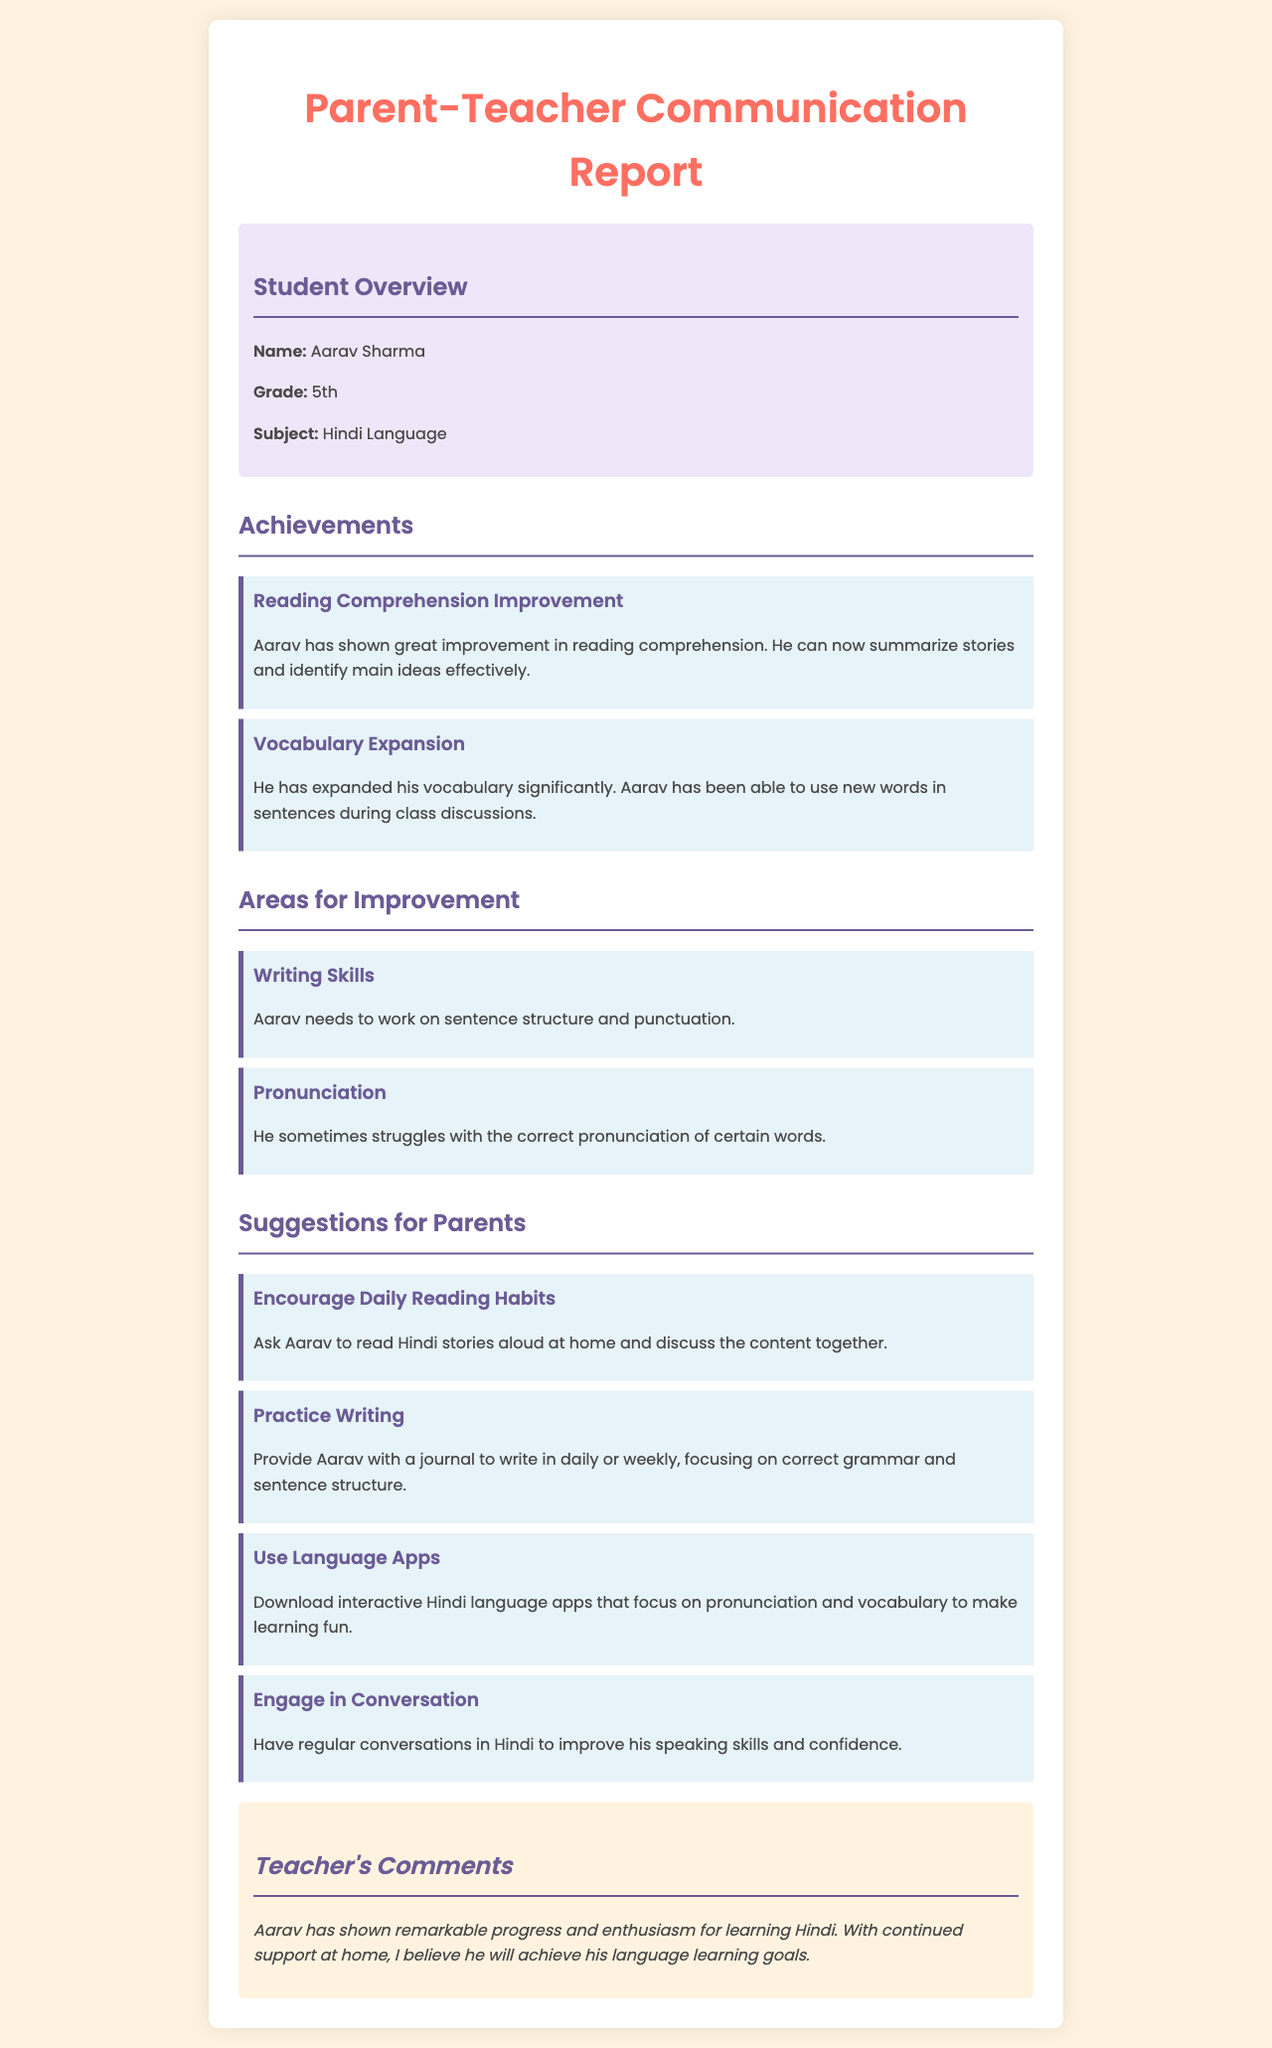What is the student's name? The student's name is clearly stated in the "Student Overview" section.
Answer: Aarav Sharma What grade is Aarav in? The grade of the student is mentioned in the same "Student Overview" section.
Answer: 5th What subject is this report focusing on? The subject for which the achievements and areas for improvement are listed is specified in the "Student Overview" section.
Answer: Hindi Language What area needs improvement related to writing? This information is found in the "Areas for Improvement" section specifically about writing skills.
Answer: Sentence structure and punctuation What has Aarav shown great improvement in? The specific achievement is detailed in the "Achievements" section focusing on reading comprehension.
Answer: Reading comprehension How should parents encourage reading habits? This suggestion is outlined in the "Suggestions for Parents" section regarding daily reading practices.
Answer: Read Hindi stories aloud What tool can parents use to improve pronunciation? This suggestion can be found in the "Suggestions for Parents" section that mentions language apps.
Answer: Language apps What does the teacher think about Aarav's progress? The teacher's overall opinion about the student's progress is summarized in the "Teacher's Comments" section.
Answer: Remarkable progress How often should Aarav practice writing? The suggestion implies consistency in the "Suggestions for Parents" section related to writing practices.
Answer: Daily or weekly 